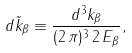Convert formula to latex. <formula><loc_0><loc_0><loc_500><loc_500>d \tilde { k } _ { \beta } \equiv \frac { d ^ { 3 } { k } _ { \beta } } { ( 2 \, \pi ) ^ { 3 } \, 2 \, E _ { \beta } } ,</formula> 